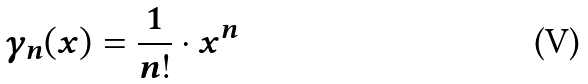<formula> <loc_0><loc_0><loc_500><loc_500>\gamma _ { n } ( x ) = \frac { 1 } { n ! } \cdot x ^ { n }</formula> 